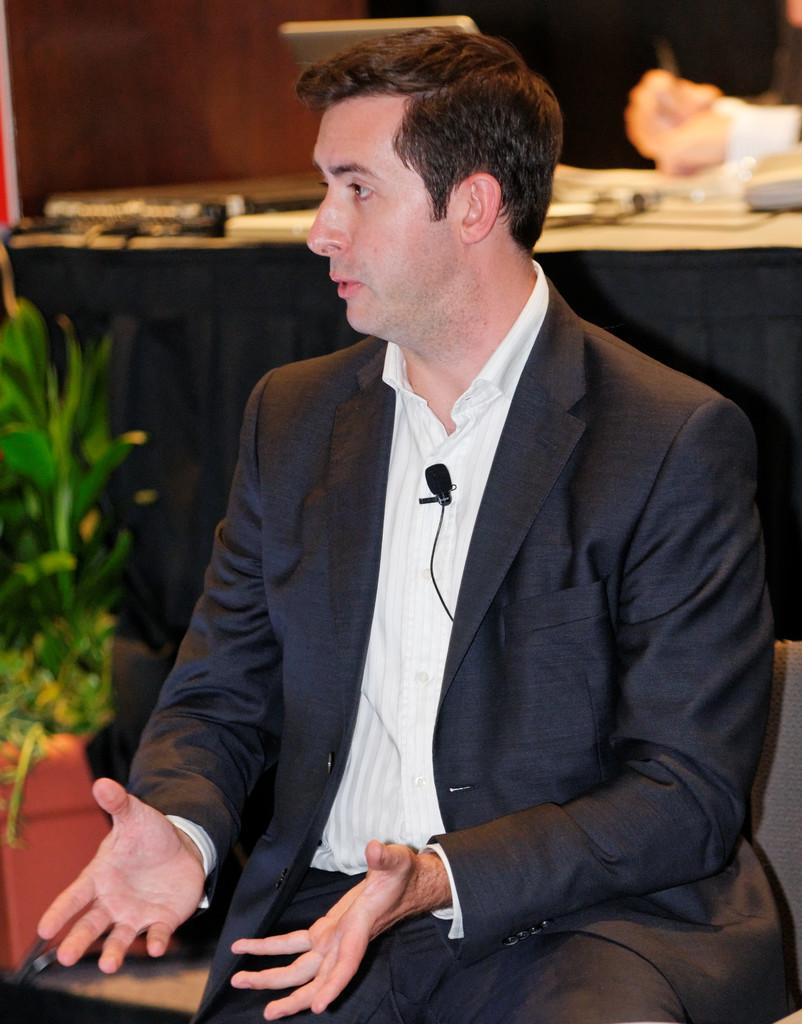Who or what is present in the image? There is a person in the image. What can be seen on the left side of the image? There is a plant on the left side of the image. What is located on the table in the image? There are objects on a table in the image. How does the goose feel about the person in the image? There is no goose present in the image, so it is not possible to determine how a goose might feel about the person. 